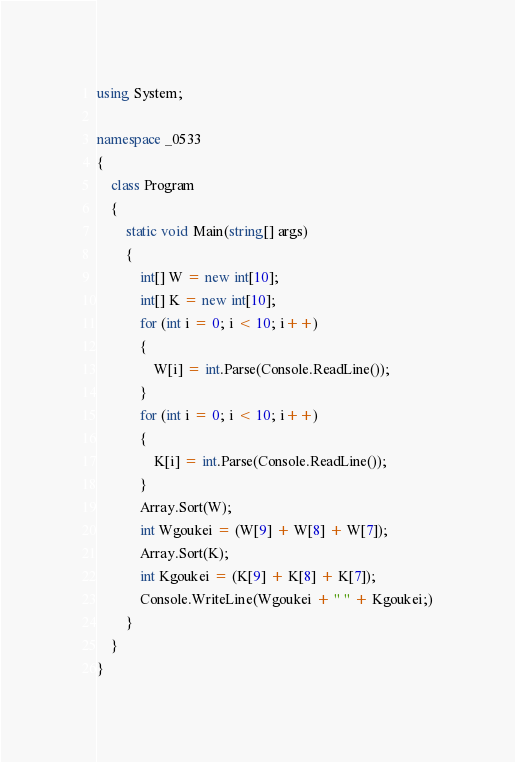Convert code to text. <code><loc_0><loc_0><loc_500><loc_500><_C#_>using System;

namespace _0533
{
    class Program
    {
        static void Main(string[] args)
        {
            int[] W = new int[10];
            int[] K = new int[10];
            for (int i = 0; i < 10; i++)
            {
                W[i] = int.Parse(Console.ReadLine());
            }
            for (int i = 0; i < 10; i++)
            {
                K[i] = int.Parse(Console.ReadLine());
            }
            Array.Sort(W);
            int Wgoukei = (W[9] + W[8] + W[7]);
            Array.Sort(K);
            int Kgoukei = (K[9] + K[8] + K[7]);
            Console.WriteLine(Wgoukei + " " + Kgoukei;)
        }
    }
}</code> 